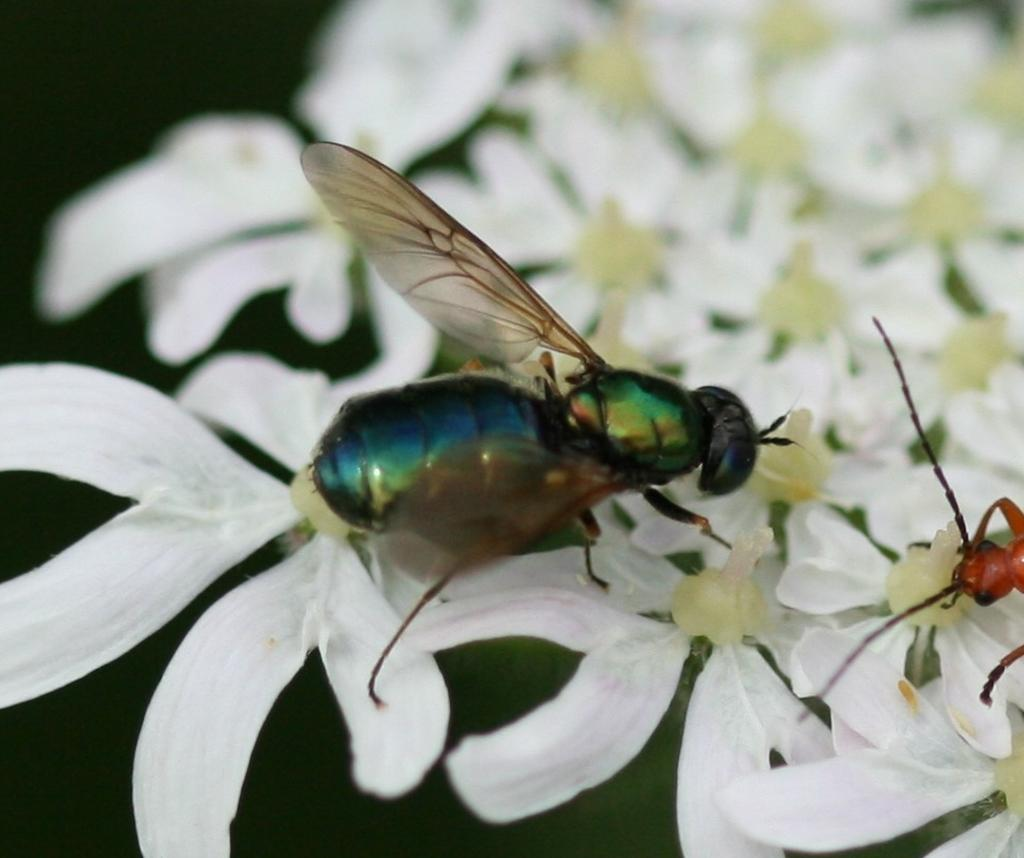What type of insect is present in the image? There is a bee in the image. What is the bee doing in the image? The bee is on white color flowers. What type of collar can be seen on the bee in the image? There is no collar present on the bee in the image. What type of bread is the bee holding in the image? There is no bread present in the image; the bee is on white color flowers. 